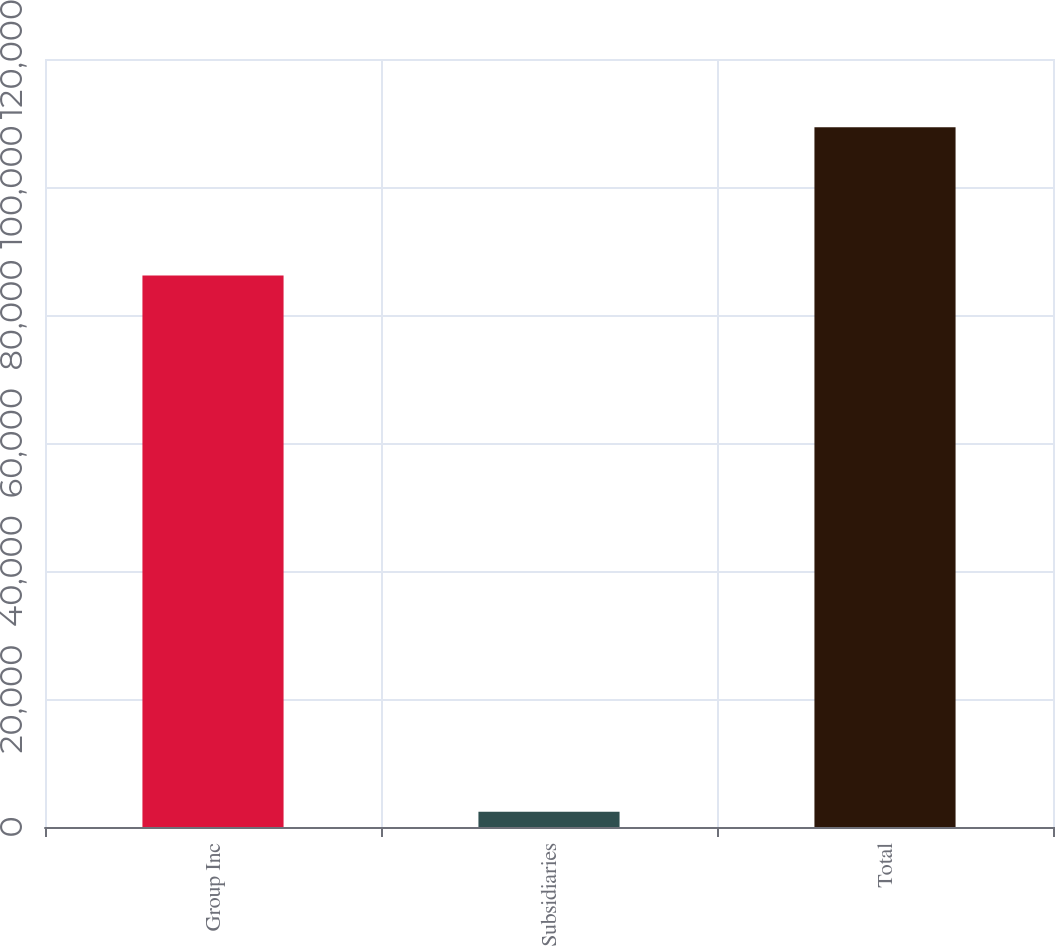Convert chart to OTSL. <chart><loc_0><loc_0><loc_500><loc_500><bar_chart><fcel>Group Inc<fcel>Subsidiaries<fcel>Total<nl><fcel>86170<fcel>2391<fcel>109355<nl></chart> 